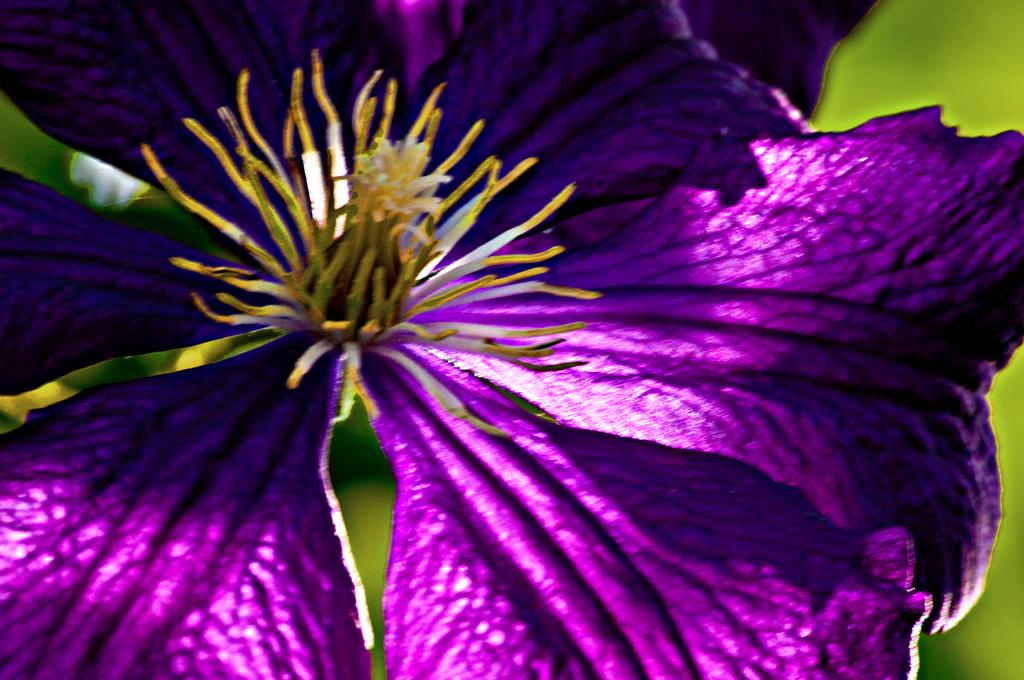What is the main subject of the image? There is a flower in the image. Can you describe the background of the image? The background of the image is blurred. Can you tell me how many rabbits are hopping around the flower in the image? There are no rabbits present in the image; it features a flower with a blurred background. What type of quartz can be seen in the image? There is no quartz present in the image. 